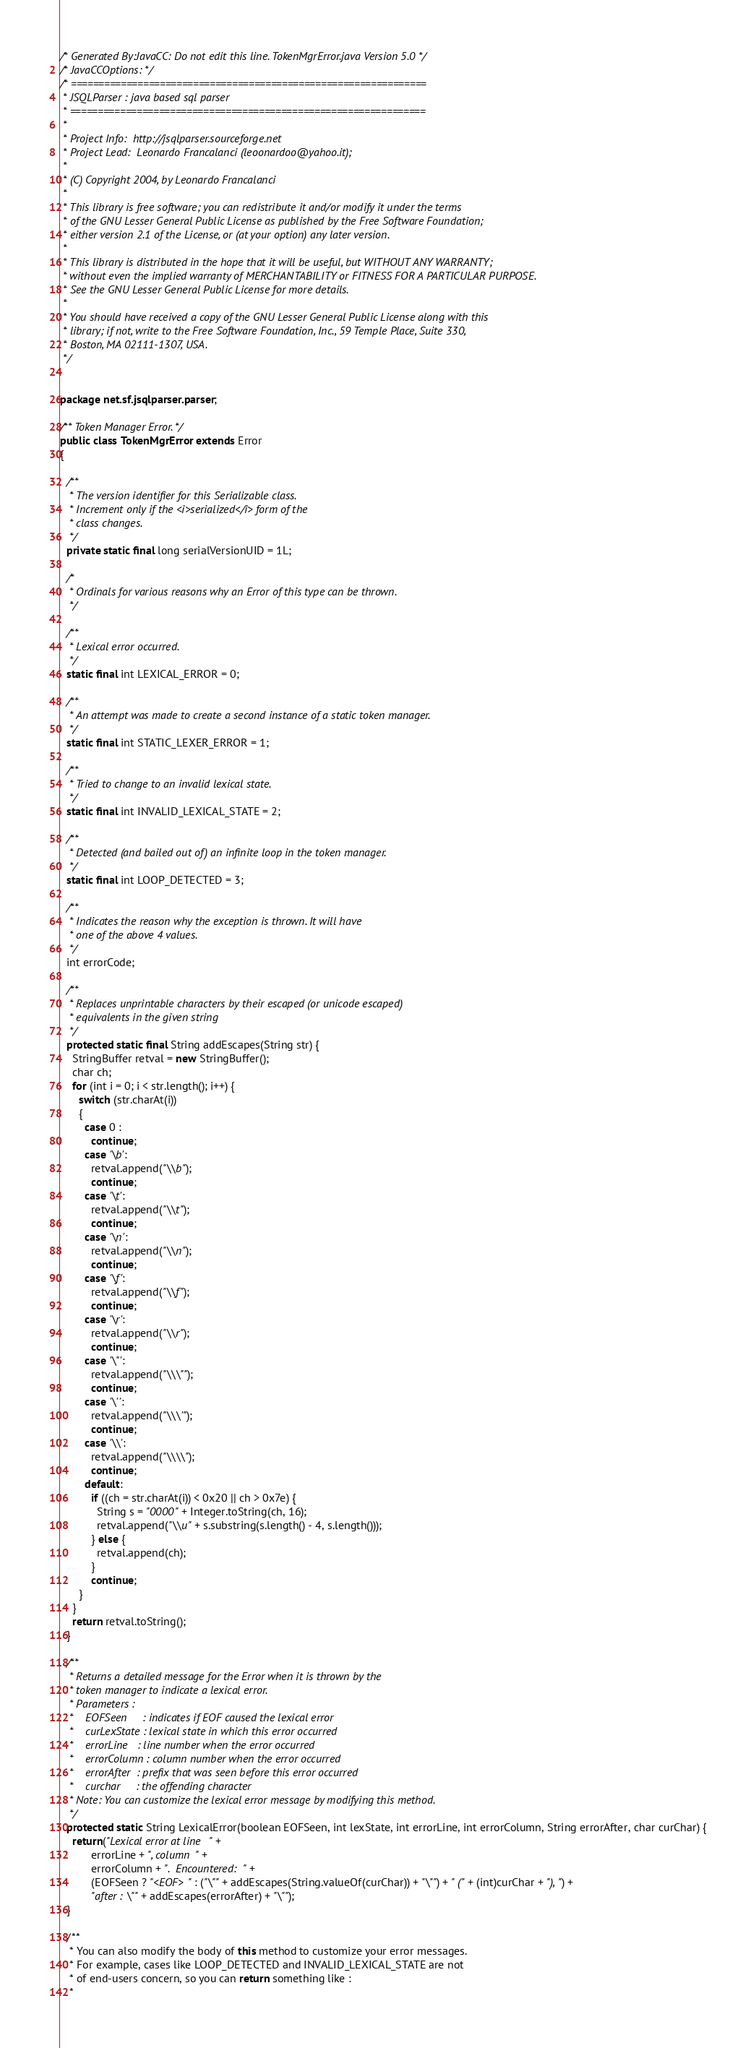Convert code to text. <code><loc_0><loc_0><loc_500><loc_500><_Java_>/* Generated By:JavaCC: Do not edit this line. TokenMgrError.java Version 5.0 */
/* JavaCCOptions: */
/* ================================================================
 * JSQLParser : java based sql parser 
 * ================================================================
 *
 * Project Info:  http://jsqlparser.sourceforge.net
 * Project Lead:  Leonardo Francalanci (leoonardoo@yahoo.it);
 *
 * (C) Copyright 2004, by Leonardo Francalanci
 *
 * This library is free software; you can redistribute it and/or modify it under the terms
 * of the GNU Lesser General Public License as published by the Free Software Foundation;
 * either version 2.1 of the License, or (at your option) any later version.
 *
 * This library is distributed in the hope that it will be useful, but WITHOUT ANY WARRANTY;
 * without even the implied warranty of MERCHANTABILITY or FITNESS FOR A PARTICULAR PURPOSE.
 * See the GNU Lesser General Public License for more details.
 *
 * You should have received a copy of the GNU Lesser General Public License along with this
 * library; if not, write to the Free Software Foundation, Inc., 59 Temple Place, Suite 330,
 * Boston, MA 02111-1307, USA.
 */


package net.sf.jsqlparser.parser;

/** Token Manager Error. */
public class TokenMgrError extends Error
{

  /**
   * The version identifier for this Serializable class.
   * Increment only if the <i>serialized</i> form of the
   * class changes.
   */
  private static final long serialVersionUID = 1L;

  /*
   * Ordinals for various reasons why an Error of this type can be thrown.
   */

  /**
   * Lexical error occurred.
   */
  static final int LEXICAL_ERROR = 0;

  /**
   * An attempt was made to create a second instance of a static token manager.
   */
  static final int STATIC_LEXER_ERROR = 1;

  /**
   * Tried to change to an invalid lexical state.
   */
  static final int INVALID_LEXICAL_STATE = 2;

  /**
   * Detected (and bailed out of) an infinite loop in the token manager.
   */
  static final int LOOP_DETECTED = 3;

  /**
   * Indicates the reason why the exception is thrown. It will have
   * one of the above 4 values.
   */
  int errorCode;

  /**
   * Replaces unprintable characters by their escaped (or unicode escaped)
   * equivalents in the given string
   */
  protected static final String addEscapes(String str) {
    StringBuffer retval = new StringBuffer();
    char ch;
    for (int i = 0; i < str.length(); i++) {
      switch (str.charAt(i))
      {
        case 0 :
          continue;
        case '\b':
          retval.append("\\b");
          continue;
        case '\t':
          retval.append("\\t");
          continue;
        case '\n':
          retval.append("\\n");
          continue;
        case '\f':
          retval.append("\\f");
          continue;
        case '\r':
          retval.append("\\r");
          continue;
        case '\"':
          retval.append("\\\"");
          continue;
        case '\'':
          retval.append("\\\'");
          continue;
        case '\\':
          retval.append("\\\\");
          continue;
        default:
          if ((ch = str.charAt(i)) < 0x20 || ch > 0x7e) {
            String s = "0000" + Integer.toString(ch, 16);
            retval.append("\\u" + s.substring(s.length() - 4, s.length()));
          } else {
            retval.append(ch);
          }
          continue;
      }
    }
    return retval.toString();
  }

  /**
   * Returns a detailed message for the Error when it is thrown by the
   * token manager to indicate a lexical error.
   * Parameters :
   *    EOFSeen     : indicates if EOF caused the lexical error
   *    curLexState : lexical state in which this error occurred
   *    errorLine   : line number when the error occurred
   *    errorColumn : column number when the error occurred
   *    errorAfter  : prefix that was seen before this error occurred
   *    curchar     : the offending character
   * Note: You can customize the lexical error message by modifying this method.
   */
  protected static String LexicalError(boolean EOFSeen, int lexState, int errorLine, int errorColumn, String errorAfter, char curChar) {
    return("Lexical error at line " +
          errorLine + ", column " +
          errorColumn + ".  Encountered: " +
          (EOFSeen ? "<EOF> " : ("\"" + addEscapes(String.valueOf(curChar)) + "\"") + " (" + (int)curChar + "), ") +
          "after : \"" + addEscapes(errorAfter) + "\"");
  }

  /**
   * You can also modify the body of this method to customize your error messages.
   * For example, cases like LOOP_DETECTED and INVALID_LEXICAL_STATE are not
   * of end-users concern, so you can return something like :
   *</code> 